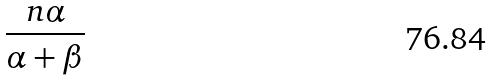<formula> <loc_0><loc_0><loc_500><loc_500>\frac { n \alpha } { \alpha + \beta }</formula> 